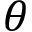Convert formula to latex. <formula><loc_0><loc_0><loc_500><loc_500>\theta</formula> 